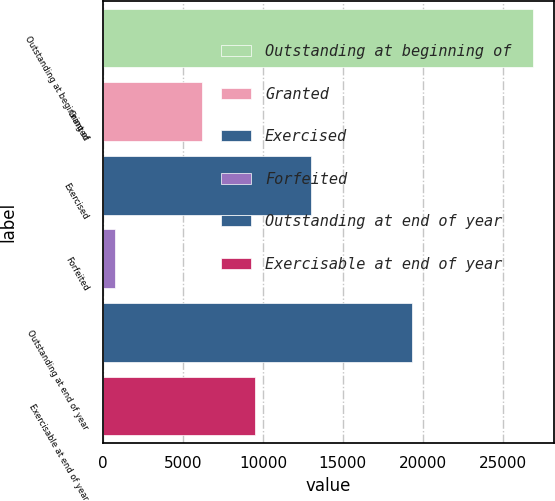Convert chart to OTSL. <chart><loc_0><loc_0><loc_500><loc_500><bar_chart><fcel>Outstanding at beginning of<fcel>Granted<fcel>Exercised<fcel>Forfeited<fcel>Outstanding at end of year<fcel>Exercisable at end of year<nl><fcel>26874<fcel>6164<fcel>13022<fcel>721<fcel>19295<fcel>9501<nl></chart> 